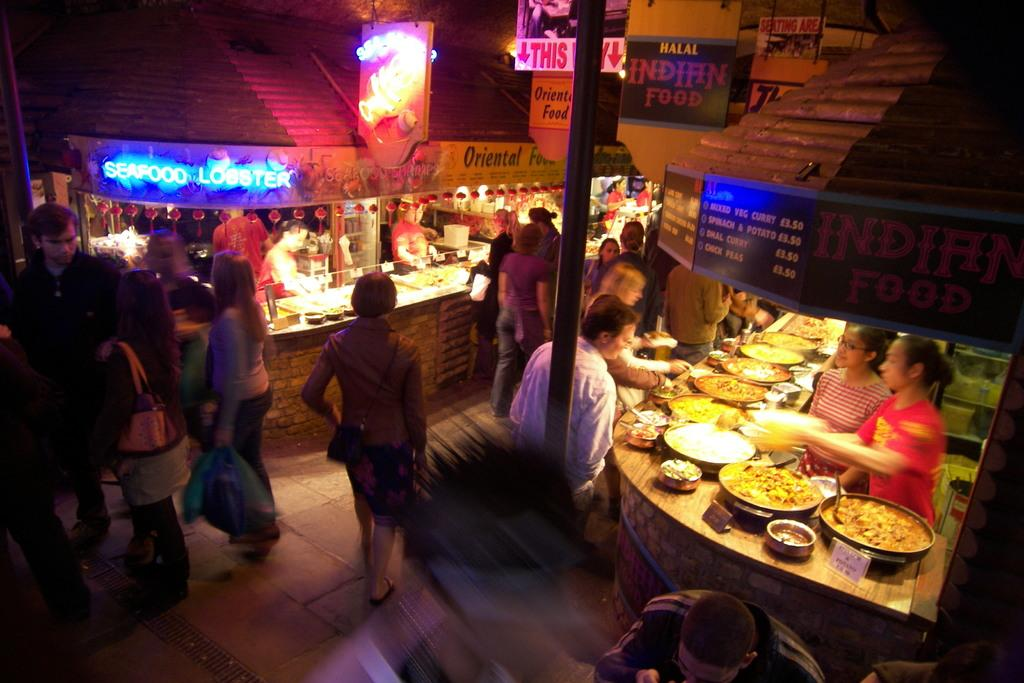What is happening in the image? There are people standing in the image. What can be seen on either side of the people? There are stalls on either side of the people. What type of letters can be seen on the tiger in the image? There is no tiger present in the image, and therefore no letters can be seen on it. 